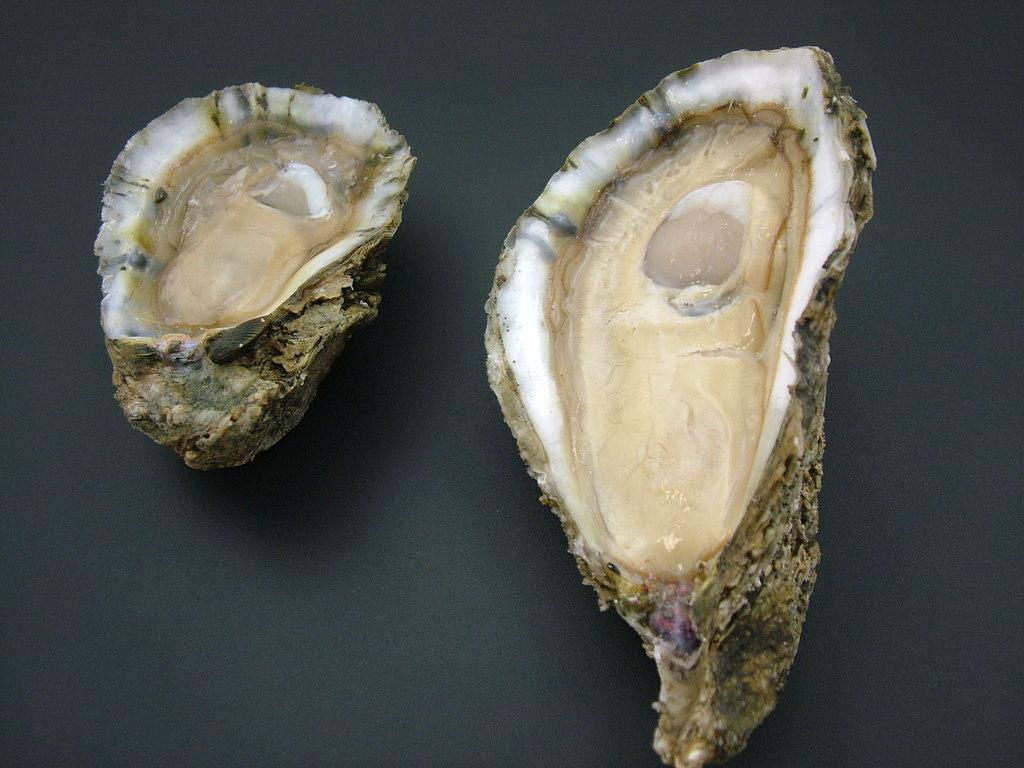Could you give a brief overview of what you see in this image? In the picture there are oysters present. 